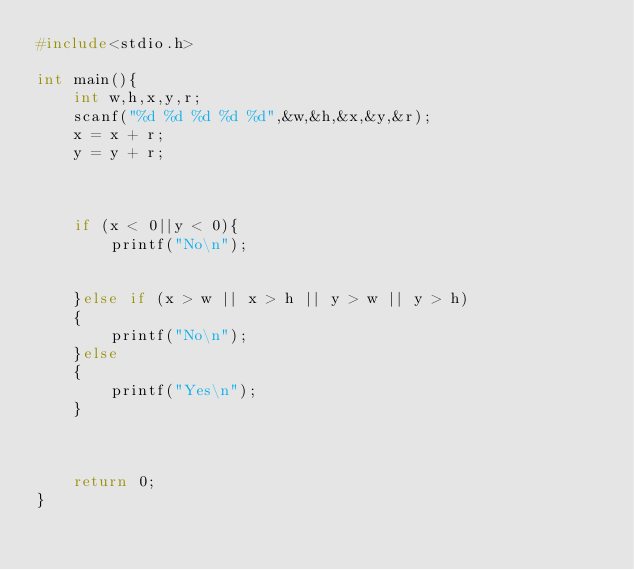<code> <loc_0><loc_0><loc_500><loc_500><_C_>#include<stdio.h>

int main(){
    int w,h,x,y,r;
    scanf("%d %d %d %d %d",&w,&h,&x,&y,&r);
    x = x + r;
    y = y + r;


    
    if (x < 0||y < 0){
        printf("No\n");

        
    }else if (x > w || x > h || y > w || y > h)
    {
        printf("No\n");
    }else
    {
        printf("Yes\n");
    }
    
    
    
    return 0;
}

</code> 